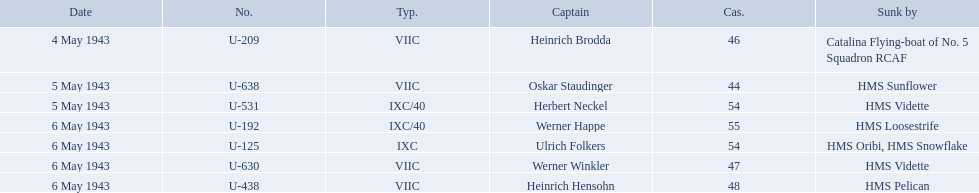Who are the captains of the u boats? Heinrich Brodda, Oskar Staudinger, Herbert Neckel, Werner Happe, Ulrich Folkers, Werner Winkler, Heinrich Hensohn. What are the dates the u boat captains were lost? 4 May 1943, 5 May 1943, 5 May 1943, 6 May 1943, 6 May 1943, 6 May 1943, 6 May 1943. Parse the full table. {'header': ['Date', 'No.', 'Typ.', 'Captain', 'Cas.', 'Sunk by'], 'rows': [['4 May 1943', 'U-209', 'VIIC', 'Heinrich Brodda', '46', 'Catalina Flying-boat of No. 5 Squadron RCAF'], ['5 May 1943', 'U-638', 'VIIC', 'Oskar Staudinger', '44', 'HMS Sunflower'], ['5 May 1943', 'U-531', 'IXC/40', 'Herbert Neckel', '54', 'HMS Vidette'], ['6 May 1943', 'U-192', 'IXC/40', 'Werner Happe', '55', 'HMS Loosestrife'], ['6 May 1943', 'U-125', 'IXC', 'Ulrich Folkers', '54', 'HMS Oribi, HMS Snowflake'], ['6 May 1943', 'U-630', 'VIIC', 'Werner Winkler', '47', 'HMS Vidette'], ['6 May 1943', 'U-438', 'VIIC', 'Heinrich Hensohn', '48', 'HMS Pelican']]} Of these, which were lost on may 5? Oskar Staudinger, Herbert Neckel. Other than oskar staudinger, who else was lost on this day? Herbert Neckel. Which were the names of the sinkers of the convoys? Catalina Flying-boat of No. 5 Squadron RCAF, HMS Sunflower, HMS Vidette, HMS Loosestrife, HMS Oribi, HMS Snowflake, HMS Vidette, HMS Pelican. What captain was sunk by the hms pelican? Heinrich Hensohn. 